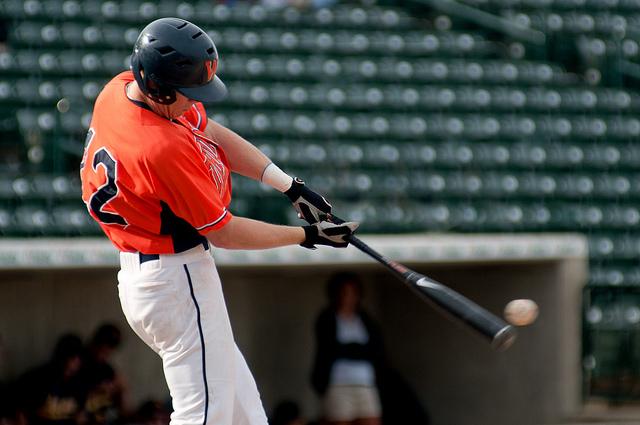Is the player right-handed?
Answer briefly. Yes. What sport is being played here?
Short answer required. Baseball. Did this mans bat break?
Concise answer only. No. What number can you see on the players shirt?
Short answer required. 2. Did the batter just hit the ball?
Keep it brief. Yes. Who is sponsoring this player?
Give a very brief answer. Nike. 